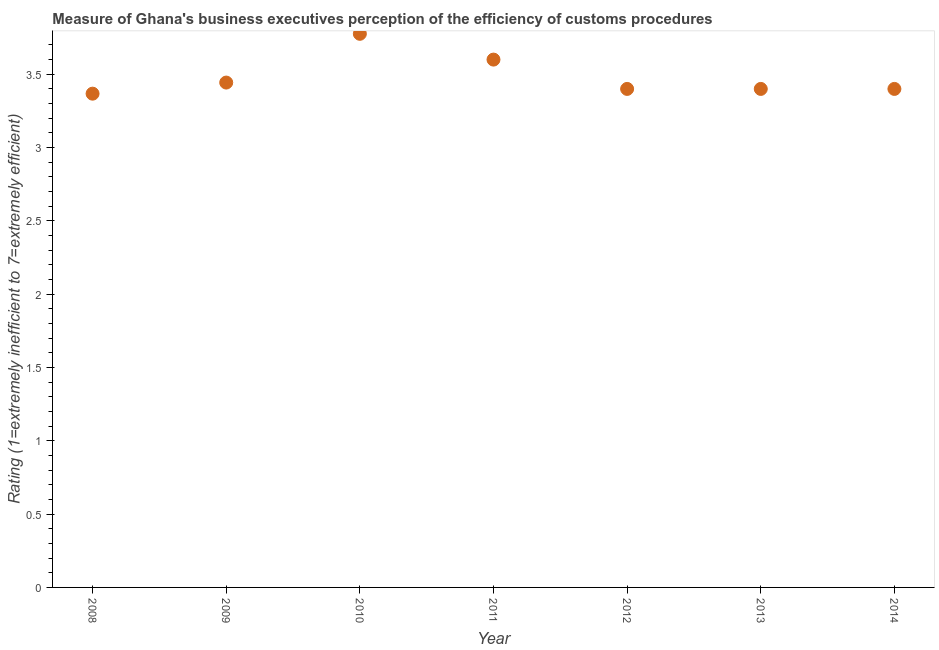What is the rating measuring burden of customs procedure in 2008?
Provide a short and direct response. 3.37. Across all years, what is the maximum rating measuring burden of customs procedure?
Keep it short and to the point. 3.78. Across all years, what is the minimum rating measuring burden of customs procedure?
Keep it short and to the point. 3.37. What is the sum of the rating measuring burden of customs procedure?
Provide a succinct answer. 24.39. What is the difference between the rating measuring burden of customs procedure in 2009 and 2010?
Keep it short and to the point. -0.33. What is the average rating measuring burden of customs procedure per year?
Give a very brief answer. 3.48. What is the median rating measuring burden of customs procedure?
Provide a short and direct response. 3.4. What is the ratio of the rating measuring burden of customs procedure in 2010 to that in 2012?
Provide a succinct answer. 1.11. Is the rating measuring burden of customs procedure in 2013 less than that in 2014?
Keep it short and to the point. No. Is the difference between the rating measuring burden of customs procedure in 2010 and 2013 greater than the difference between any two years?
Provide a succinct answer. No. What is the difference between the highest and the second highest rating measuring burden of customs procedure?
Provide a succinct answer. 0.18. What is the difference between the highest and the lowest rating measuring burden of customs procedure?
Ensure brevity in your answer.  0.41. Does the rating measuring burden of customs procedure monotonically increase over the years?
Offer a terse response. No. How many years are there in the graph?
Ensure brevity in your answer.  7. What is the difference between two consecutive major ticks on the Y-axis?
Make the answer very short. 0.5. Does the graph contain grids?
Your answer should be very brief. No. What is the title of the graph?
Make the answer very short. Measure of Ghana's business executives perception of the efficiency of customs procedures. What is the label or title of the X-axis?
Your answer should be very brief. Year. What is the label or title of the Y-axis?
Give a very brief answer. Rating (1=extremely inefficient to 7=extremely efficient). What is the Rating (1=extremely inefficient to 7=extremely efficient) in 2008?
Your answer should be compact. 3.37. What is the Rating (1=extremely inefficient to 7=extremely efficient) in 2009?
Provide a succinct answer. 3.44. What is the Rating (1=extremely inefficient to 7=extremely efficient) in 2010?
Provide a succinct answer. 3.78. What is the Rating (1=extremely inefficient to 7=extremely efficient) in 2014?
Provide a succinct answer. 3.4. What is the difference between the Rating (1=extremely inefficient to 7=extremely efficient) in 2008 and 2009?
Your answer should be compact. -0.08. What is the difference between the Rating (1=extremely inefficient to 7=extremely efficient) in 2008 and 2010?
Your answer should be compact. -0.41. What is the difference between the Rating (1=extremely inefficient to 7=extremely efficient) in 2008 and 2011?
Offer a very short reply. -0.23. What is the difference between the Rating (1=extremely inefficient to 7=extremely efficient) in 2008 and 2012?
Keep it short and to the point. -0.03. What is the difference between the Rating (1=extremely inefficient to 7=extremely efficient) in 2008 and 2013?
Offer a very short reply. -0.03. What is the difference between the Rating (1=extremely inefficient to 7=extremely efficient) in 2008 and 2014?
Your answer should be compact. -0.03. What is the difference between the Rating (1=extremely inefficient to 7=extremely efficient) in 2009 and 2010?
Provide a succinct answer. -0.33. What is the difference between the Rating (1=extremely inefficient to 7=extremely efficient) in 2009 and 2011?
Offer a terse response. -0.16. What is the difference between the Rating (1=extremely inefficient to 7=extremely efficient) in 2009 and 2012?
Offer a very short reply. 0.04. What is the difference between the Rating (1=extremely inefficient to 7=extremely efficient) in 2009 and 2013?
Offer a very short reply. 0.04. What is the difference between the Rating (1=extremely inefficient to 7=extremely efficient) in 2009 and 2014?
Offer a terse response. 0.04. What is the difference between the Rating (1=extremely inefficient to 7=extremely efficient) in 2010 and 2011?
Provide a short and direct response. 0.18. What is the difference between the Rating (1=extremely inefficient to 7=extremely efficient) in 2010 and 2012?
Provide a short and direct response. 0.38. What is the difference between the Rating (1=extremely inefficient to 7=extremely efficient) in 2010 and 2013?
Ensure brevity in your answer.  0.38. What is the difference between the Rating (1=extremely inefficient to 7=extremely efficient) in 2010 and 2014?
Provide a short and direct response. 0.38. What is the difference between the Rating (1=extremely inefficient to 7=extremely efficient) in 2012 and 2013?
Your answer should be compact. 0. What is the ratio of the Rating (1=extremely inefficient to 7=extremely efficient) in 2008 to that in 2010?
Provide a short and direct response. 0.89. What is the ratio of the Rating (1=extremely inefficient to 7=extremely efficient) in 2008 to that in 2011?
Provide a succinct answer. 0.94. What is the ratio of the Rating (1=extremely inefficient to 7=extremely efficient) in 2008 to that in 2013?
Your answer should be very brief. 0.99. What is the ratio of the Rating (1=extremely inefficient to 7=extremely efficient) in 2009 to that in 2010?
Keep it short and to the point. 0.91. What is the ratio of the Rating (1=extremely inefficient to 7=extremely efficient) in 2009 to that in 2011?
Make the answer very short. 0.96. What is the ratio of the Rating (1=extremely inefficient to 7=extremely efficient) in 2009 to that in 2013?
Your answer should be compact. 1.01. What is the ratio of the Rating (1=extremely inefficient to 7=extremely efficient) in 2010 to that in 2011?
Provide a succinct answer. 1.05. What is the ratio of the Rating (1=extremely inefficient to 7=extremely efficient) in 2010 to that in 2012?
Provide a short and direct response. 1.11. What is the ratio of the Rating (1=extremely inefficient to 7=extremely efficient) in 2010 to that in 2013?
Keep it short and to the point. 1.11. What is the ratio of the Rating (1=extremely inefficient to 7=extremely efficient) in 2010 to that in 2014?
Ensure brevity in your answer.  1.11. What is the ratio of the Rating (1=extremely inefficient to 7=extremely efficient) in 2011 to that in 2012?
Your response must be concise. 1.06. What is the ratio of the Rating (1=extremely inefficient to 7=extremely efficient) in 2011 to that in 2013?
Ensure brevity in your answer.  1.06. What is the ratio of the Rating (1=extremely inefficient to 7=extremely efficient) in 2011 to that in 2014?
Offer a very short reply. 1.06. 